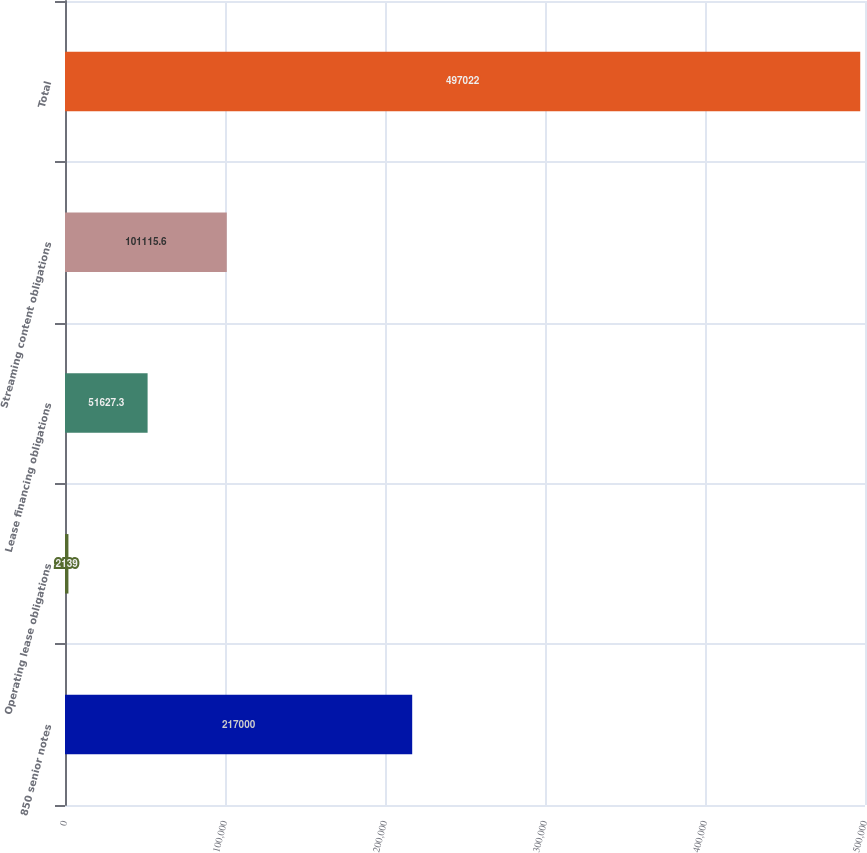Convert chart to OTSL. <chart><loc_0><loc_0><loc_500><loc_500><bar_chart><fcel>850 senior notes<fcel>Operating lease obligations<fcel>Lease financing obligations<fcel>Streaming content obligations<fcel>Total<nl><fcel>217000<fcel>2139<fcel>51627.3<fcel>101116<fcel>497022<nl></chart> 